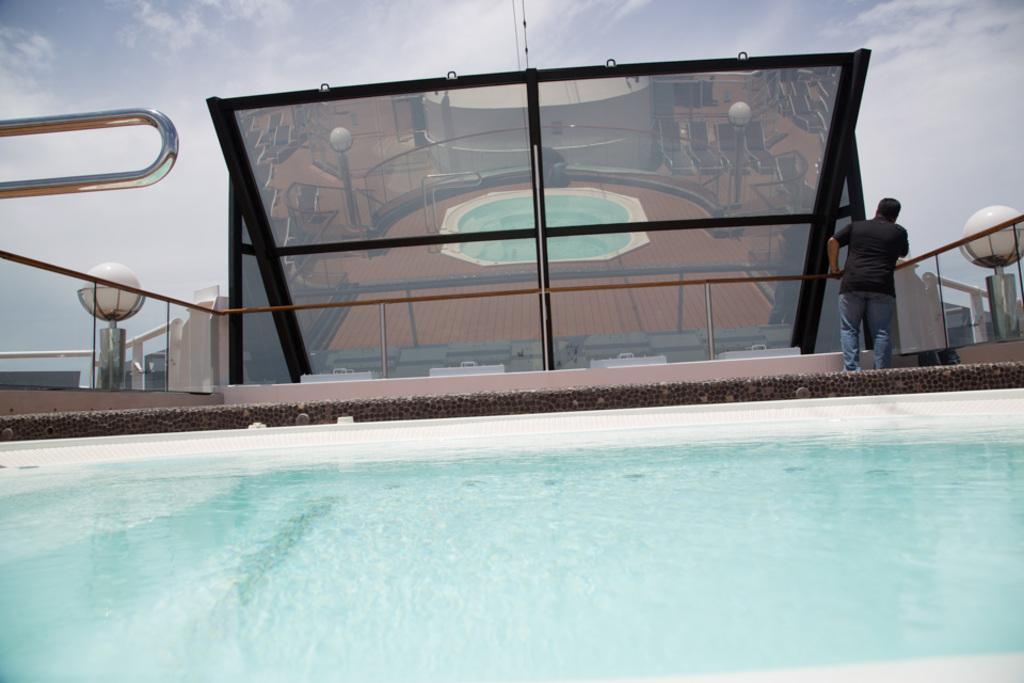In one or two sentences, can you explain what this image depicts? In the foreground of the image we can see water. In the center of the image we can see a person wearing a black t shirt is standing on the floor holding a rod in his hand. In the background, we can see a mirror, group of poles and the cloudy sky. 